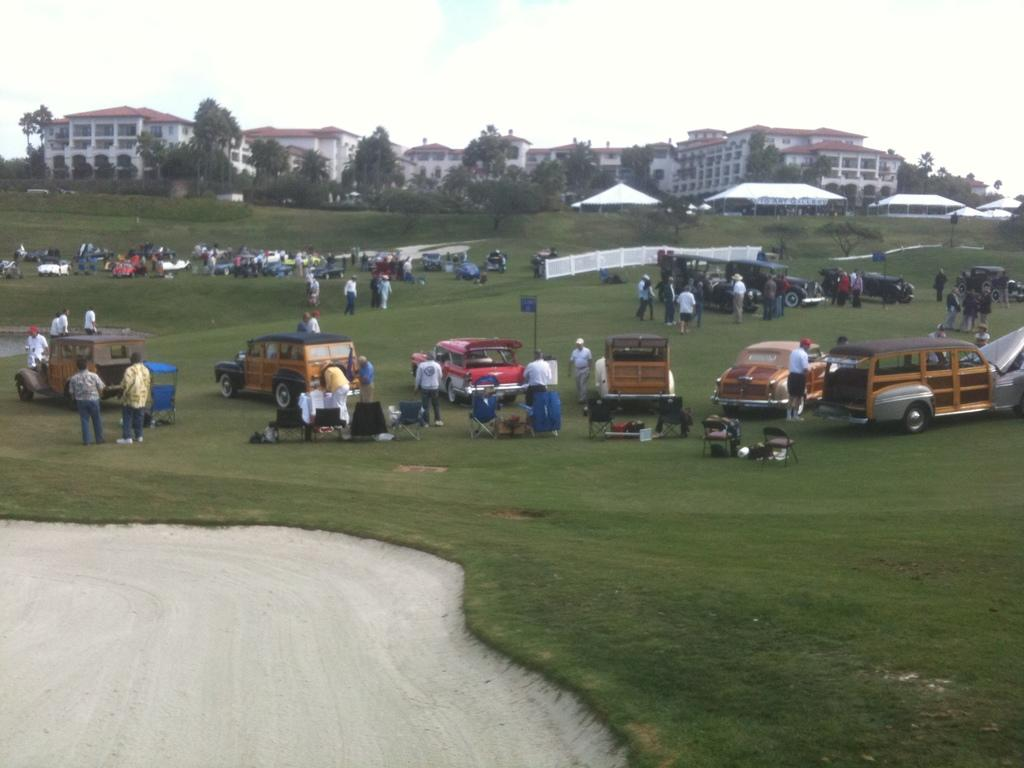What type of vegetation can be seen in the image? There is grass in the image. What type of pathway is visible in the image? There is a road in the image. What are the people in the image doing? The people are standing in a group in the image. What can be seen near the people in the image? There are vehicles parked in the image. What can be seen in the distance in the image? There are trees and buildings in the background of the image. What type of reward is being given to the brick in the image? There is no brick or reward present in the image. How does the stop sign affect the movement of the vehicles in the image? There is no stop sign mentioned in the image, so its effect on the vehicles cannot be determined. 